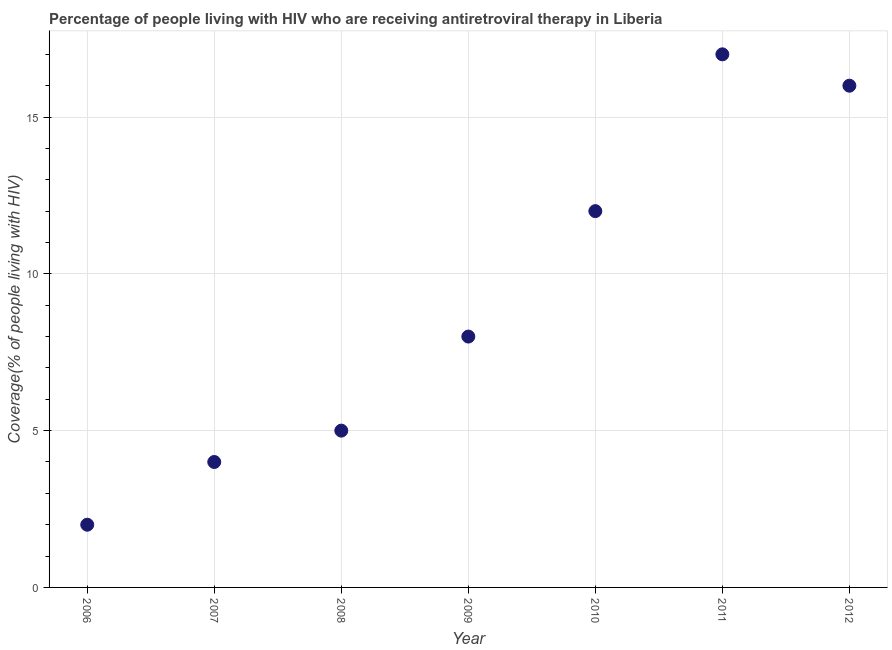What is the antiretroviral therapy coverage in 2008?
Ensure brevity in your answer.  5. Across all years, what is the maximum antiretroviral therapy coverage?
Your response must be concise. 17. Across all years, what is the minimum antiretroviral therapy coverage?
Ensure brevity in your answer.  2. What is the sum of the antiretroviral therapy coverage?
Offer a very short reply. 64. What is the difference between the antiretroviral therapy coverage in 2007 and 2012?
Your answer should be very brief. -12. What is the average antiretroviral therapy coverage per year?
Your response must be concise. 9.14. In how many years, is the antiretroviral therapy coverage greater than 11 %?
Offer a terse response. 3. Do a majority of the years between 2006 and 2010 (inclusive) have antiretroviral therapy coverage greater than 3 %?
Keep it short and to the point. Yes. What is the ratio of the antiretroviral therapy coverage in 2007 to that in 2008?
Your answer should be very brief. 0.8. What is the difference between the highest and the lowest antiretroviral therapy coverage?
Make the answer very short. 15. In how many years, is the antiretroviral therapy coverage greater than the average antiretroviral therapy coverage taken over all years?
Your answer should be very brief. 3. Does the antiretroviral therapy coverage monotonically increase over the years?
Give a very brief answer. No. How many dotlines are there?
Make the answer very short. 1. How many years are there in the graph?
Offer a terse response. 7. What is the difference between two consecutive major ticks on the Y-axis?
Your answer should be compact. 5. Does the graph contain grids?
Your response must be concise. Yes. What is the title of the graph?
Provide a succinct answer. Percentage of people living with HIV who are receiving antiretroviral therapy in Liberia. What is the label or title of the Y-axis?
Offer a very short reply. Coverage(% of people living with HIV). What is the Coverage(% of people living with HIV) in 2007?
Provide a short and direct response. 4. What is the Coverage(% of people living with HIV) in 2008?
Make the answer very short. 5. What is the Coverage(% of people living with HIV) in 2010?
Provide a short and direct response. 12. What is the Coverage(% of people living with HIV) in 2011?
Your answer should be very brief. 17. What is the Coverage(% of people living with HIV) in 2012?
Make the answer very short. 16. What is the difference between the Coverage(% of people living with HIV) in 2006 and 2011?
Keep it short and to the point. -15. What is the difference between the Coverage(% of people living with HIV) in 2006 and 2012?
Offer a terse response. -14. What is the difference between the Coverage(% of people living with HIV) in 2007 and 2008?
Your answer should be very brief. -1. What is the difference between the Coverage(% of people living with HIV) in 2007 and 2009?
Your response must be concise. -4. What is the difference between the Coverage(% of people living with HIV) in 2007 and 2010?
Ensure brevity in your answer.  -8. What is the difference between the Coverage(% of people living with HIV) in 2008 and 2009?
Provide a succinct answer. -3. What is the difference between the Coverage(% of people living with HIV) in 2008 and 2010?
Provide a succinct answer. -7. What is the difference between the Coverage(% of people living with HIV) in 2009 and 2010?
Make the answer very short. -4. What is the ratio of the Coverage(% of people living with HIV) in 2006 to that in 2007?
Offer a terse response. 0.5. What is the ratio of the Coverage(% of people living with HIV) in 2006 to that in 2008?
Offer a very short reply. 0.4. What is the ratio of the Coverage(% of people living with HIV) in 2006 to that in 2009?
Your answer should be compact. 0.25. What is the ratio of the Coverage(% of people living with HIV) in 2006 to that in 2010?
Offer a terse response. 0.17. What is the ratio of the Coverage(% of people living with HIV) in 2006 to that in 2011?
Make the answer very short. 0.12. What is the ratio of the Coverage(% of people living with HIV) in 2006 to that in 2012?
Ensure brevity in your answer.  0.12. What is the ratio of the Coverage(% of people living with HIV) in 2007 to that in 2008?
Your answer should be compact. 0.8. What is the ratio of the Coverage(% of people living with HIV) in 2007 to that in 2010?
Your response must be concise. 0.33. What is the ratio of the Coverage(% of people living with HIV) in 2007 to that in 2011?
Make the answer very short. 0.23. What is the ratio of the Coverage(% of people living with HIV) in 2008 to that in 2010?
Offer a very short reply. 0.42. What is the ratio of the Coverage(% of people living with HIV) in 2008 to that in 2011?
Your answer should be compact. 0.29. What is the ratio of the Coverage(% of people living with HIV) in 2008 to that in 2012?
Provide a succinct answer. 0.31. What is the ratio of the Coverage(% of people living with HIV) in 2009 to that in 2010?
Offer a very short reply. 0.67. What is the ratio of the Coverage(% of people living with HIV) in 2009 to that in 2011?
Your answer should be compact. 0.47. What is the ratio of the Coverage(% of people living with HIV) in 2010 to that in 2011?
Your response must be concise. 0.71. What is the ratio of the Coverage(% of people living with HIV) in 2011 to that in 2012?
Provide a short and direct response. 1.06. 